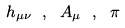<formula> <loc_0><loc_0><loc_500><loc_500>h _ { \mu \nu } \ , \ A _ { \mu } \ , \ \pi</formula> 